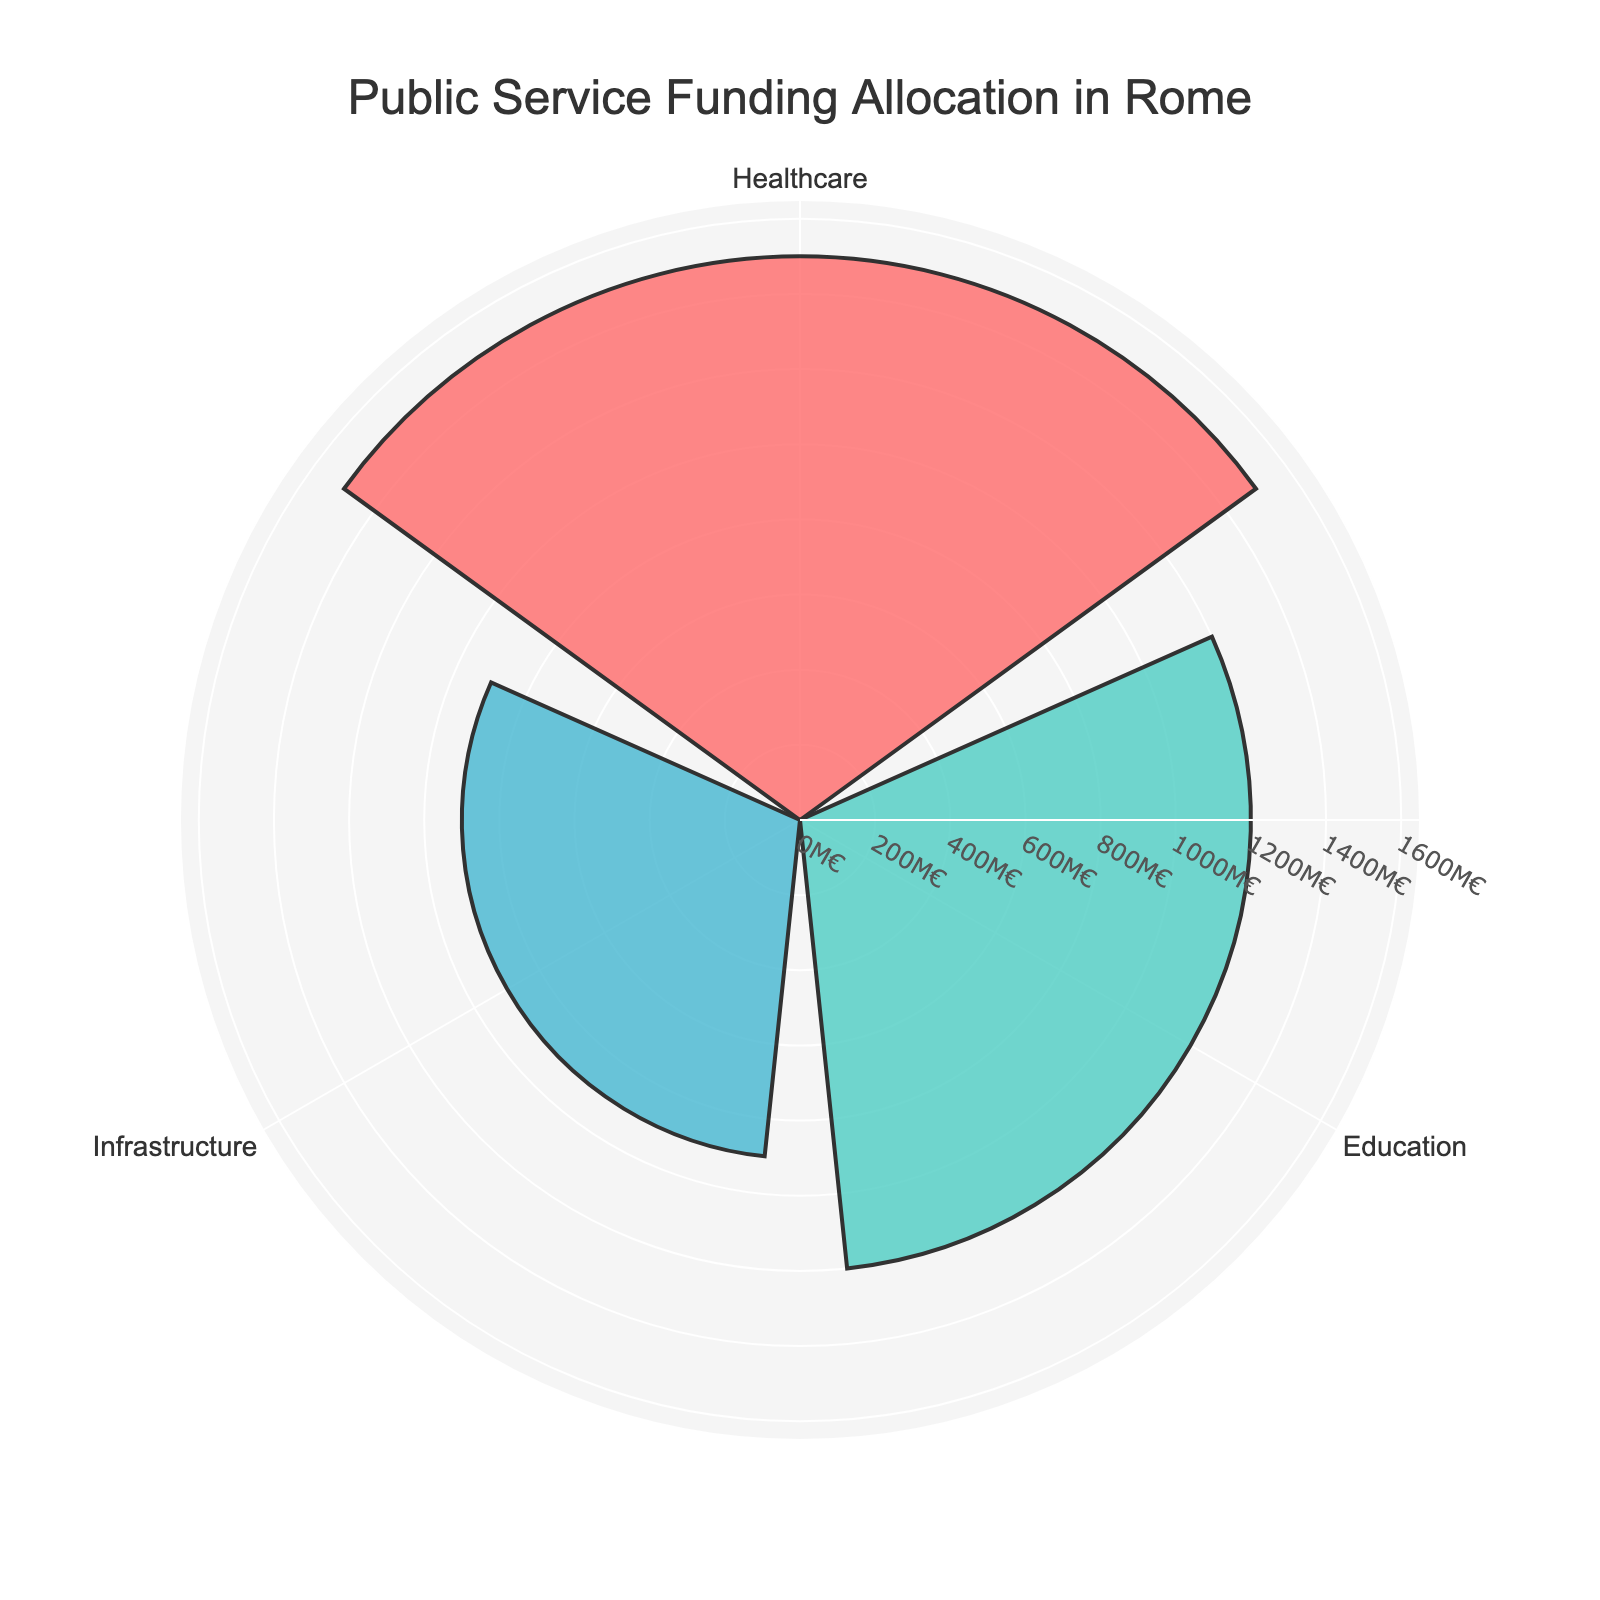What is the title of the plot? The title is located at the top center of the plot and provides a brief summary of what the chart represents. It reads "Public Service Funding Allocation in Rome."
Answer: Public Service Funding Allocation in Rome How many categories are represented in the chart? The chart has segments for each category. By visually inspecting, we see three segments labeled as "Healthcare", "Education", and "Infrastructure".
Answer: 3 Which category received the highest funding? To determine the highest funding, look for the segment with the largest radius. The "Healthcare" segment has the largest radius.
Answer: Healthcare How much funding was allocated to infrastructure? The amount corresponding to the "Infrastructure" segment is labeled as 900M€. This can be directly seen from the label or segment.
Answer: 900M€ What is the difference in funding between Healthcare and Education? To find the difference, subtract the funding amount of Education (1200M€) from Healthcare (1500M€): 1500M€ - 1200M€ = 300M€.
Answer: 300M€ What is the total funding allocated across all categories? Sum up the funding amounts for all categories: Healthcare (1500M€) + Education (1200M€) + Infrastructure (900M€): 1500M€ + 1200M€ + 900M€ = 3600M€.
Answer: 3600M€ Which category received the least funding? Identify the segment with the smallest radius. The "Infrastructure" segment is the smallest.
Answer: Infrastructure By how much does the healthcare funding exceed the infrastructure funding? Subtract the funding amount for Infrastructure (900M€) from the funding amount for Healthcare (1500M€): 1500M€ - 900M€ = 600M€.
Answer: 600M€ What percentage of the total funding is allocated to education? To calculate the percentage: (Funding for Education / Total Funding) * 100. First, find the total funding which is 3600M€ (from a previous question). Then, (1200M€ / 3600M€) * 100 = 33.33%.
Answer: 33.33% What colors represent the categories in the chart? Observe the colors in the chart segments. The segments are colored as follows: Healthcare is red, Education is green, and Infrastructure is blue.
Answer: Red, Green, Blue 